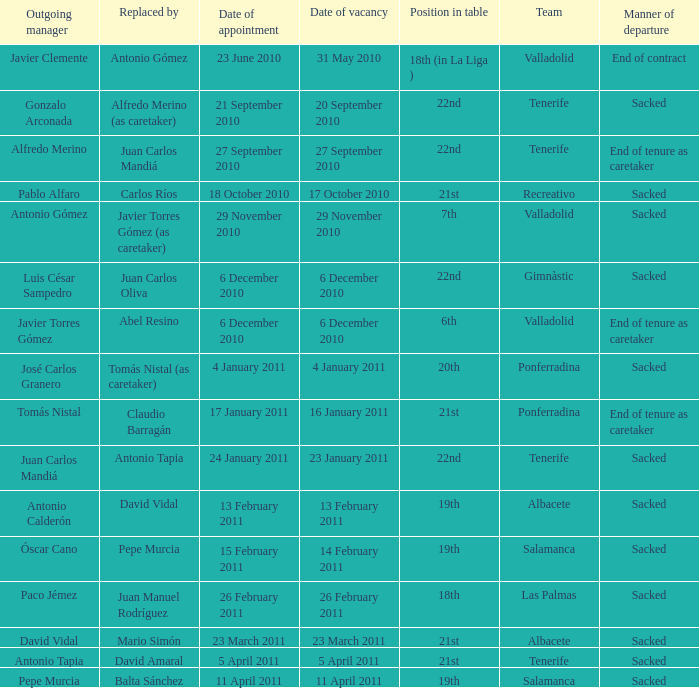What was the position of appointment date 17 january 2011 21st. 